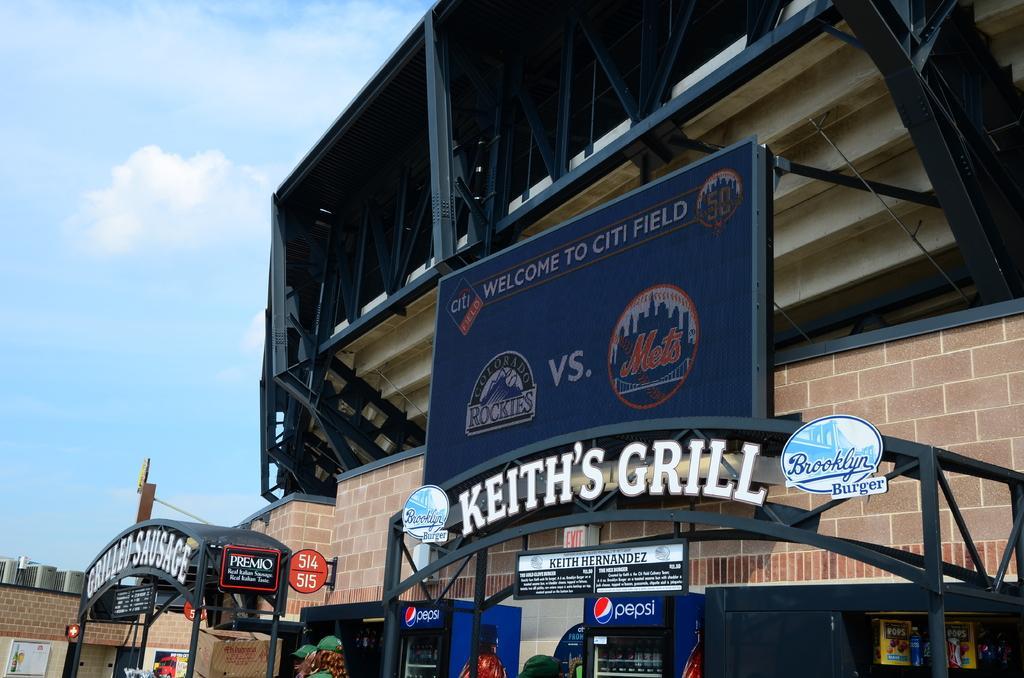Please provide a concise description of this image. In this image there are buildings, boards, poles and there is text and fridges and some people and also there are some objects. At the top there is sky. 